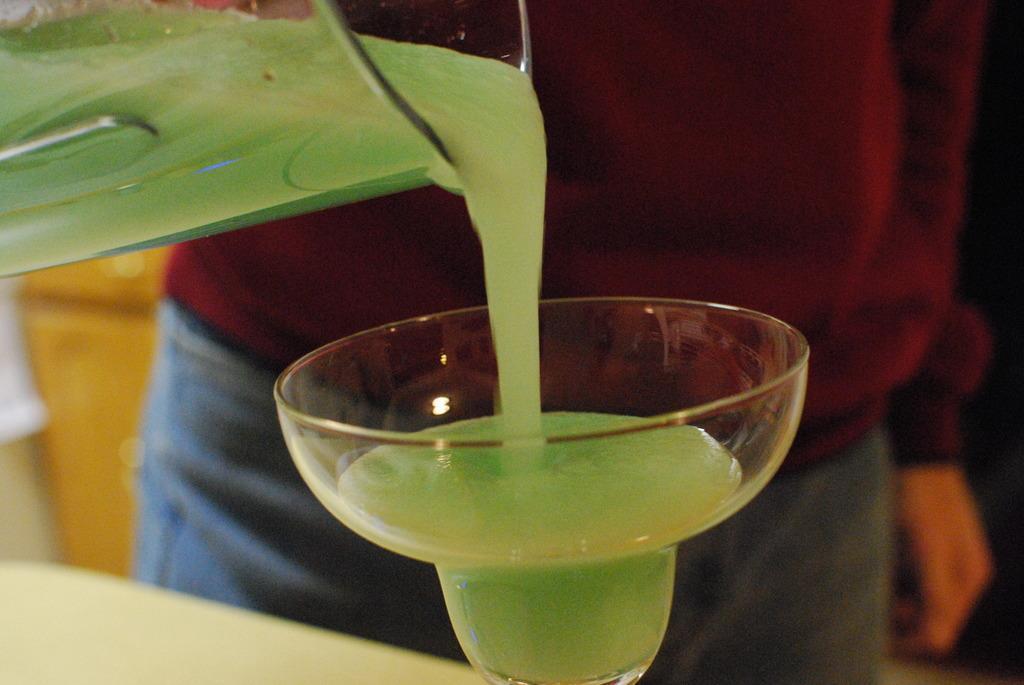Could you give a brief overview of what you see in this image? In the center of the image a person is standing and holding a mug and pouring a liquid in cup. At the bottom of the image there is a table. On the table a cup is there. 